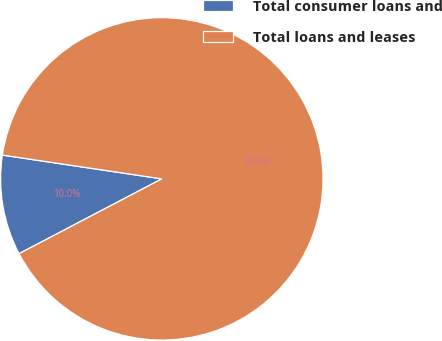Convert chart. <chart><loc_0><loc_0><loc_500><loc_500><pie_chart><fcel>Total consumer loans and<fcel>Total loans and leases<nl><fcel>10.04%<fcel>89.96%<nl></chart> 